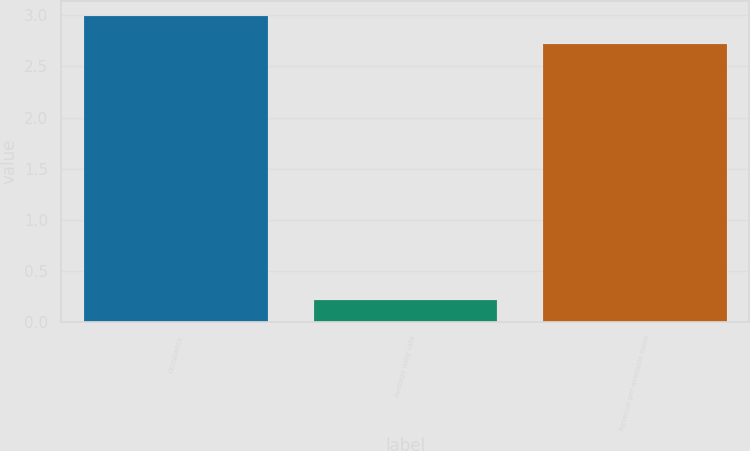<chart> <loc_0><loc_0><loc_500><loc_500><bar_chart><fcel>Occupancy<fcel>Average daily rate<fcel>Revenue per available room<nl><fcel>2.99<fcel>0.21<fcel>2.72<nl></chart> 